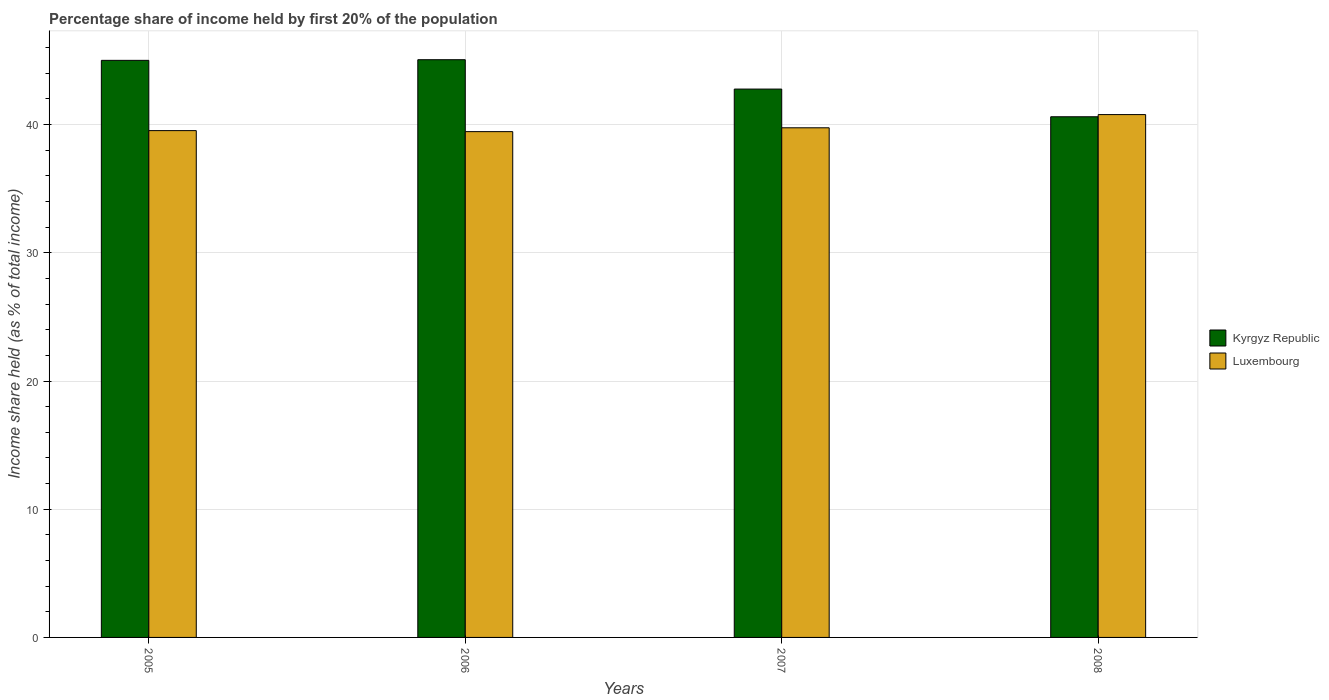How many groups of bars are there?
Provide a short and direct response. 4. How many bars are there on the 3rd tick from the left?
Offer a very short reply. 2. In how many cases, is the number of bars for a given year not equal to the number of legend labels?
Offer a very short reply. 0. What is the share of income held by first 20% of the population in Kyrgyz Republic in 2006?
Provide a short and direct response. 45.06. Across all years, what is the maximum share of income held by first 20% of the population in Luxembourg?
Make the answer very short. 40.78. Across all years, what is the minimum share of income held by first 20% of the population in Kyrgyz Republic?
Your response must be concise. 40.61. In which year was the share of income held by first 20% of the population in Luxembourg maximum?
Make the answer very short. 2008. In which year was the share of income held by first 20% of the population in Luxembourg minimum?
Offer a very short reply. 2006. What is the total share of income held by first 20% of the population in Kyrgyz Republic in the graph?
Provide a succinct answer. 173.45. What is the difference between the share of income held by first 20% of the population in Luxembourg in 2006 and that in 2007?
Keep it short and to the point. -0.3. What is the difference between the share of income held by first 20% of the population in Kyrgyz Republic in 2005 and the share of income held by first 20% of the population in Luxembourg in 2006?
Your answer should be compact. 5.56. What is the average share of income held by first 20% of the population in Kyrgyz Republic per year?
Offer a terse response. 43.36. In the year 2006, what is the difference between the share of income held by first 20% of the population in Luxembourg and share of income held by first 20% of the population in Kyrgyz Republic?
Provide a succinct answer. -5.61. What is the ratio of the share of income held by first 20% of the population in Kyrgyz Republic in 2005 to that in 2007?
Provide a short and direct response. 1.05. Is the difference between the share of income held by first 20% of the population in Luxembourg in 2006 and 2007 greater than the difference between the share of income held by first 20% of the population in Kyrgyz Republic in 2006 and 2007?
Ensure brevity in your answer.  No. What is the difference between the highest and the second highest share of income held by first 20% of the population in Luxembourg?
Your answer should be very brief. 1.03. What is the difference between the highest and the lowest share of income held by first 20% of the population in Kyrgyz Republic?
Your response must be concise. 4.45. What does the 1st bar from the left in 2005 represents?
Provide a succinct answer. Kyrgyz Republic. What does the 2nd bar from the right in 2007 represents?
Your response must be concise. Kyrgyz Republic. How many bars are there?
Make the answer very short. 8. How many years are there in the graph?
Your answer should be compact. 4. Does the graph contain grids?
Keep it short and to the point. Yes. Where does the legend appear in the graph?
Ensure brevity in your answer.  Center right. How many legend labels are there?
Your answer should be very brief. 2. How are the legend labels stacked?
Provide a short and direct response. Vertical. What is the title of the graph?
Offer a terse response. Percentage share of income held by first 20% of the population. Does "Colombia" appear as one of the legend labels in the graph?
Give a very brief answer. No. What is the label or title of the Y-axis?
Ensure brevity in your answer.  Income share held (as % of total income). What is the Income share held (as % of total income) of Kyrgyz Republic in 2005?
Keep it short and to the point. 45.01. What is the Income share held (as % of total income) in Luxembourg in 2005?
Your answer should be very brief. 39.53. What is the Income share held (as % of total income) in Kyrgyz Republic in 2006?
Give a very brief answer. 45.06. What is the Income share held (as % of total income) in Luxembourg in 2006?
Make the answer very short. 39.45. What is the Income share held (as % of total income) of Kyrgyz Republic in 2007?
Ensure brevity in your answer.  42.77. What is the Income share held (as % of total income) in Luxembourg in 2007?
Your response must be concise. 39.75. What is the Income share held (as % of total income) of Kyrgyz Republic in 2008?
Provide a succinct answer. 40.61. What is the Income share held (as % of total income) in Luxembourg in 2008?
Give a very brief answer. 40.78. Across all years, what is the maximum Income share held (as % of total income) of Kyrgyz Republic?
Give a very brief answer. 45.06. Across all years, what is the maximum Income share held (as % of total income) in Luxembourg?
Keep it short and to the point. 40.78. Across all years, what is the minimum Income share held (as % of total income) in Kyrgyz Republic?
Your answer should be very brief. 40.61. Across all years, what is the minimum Income share held (as % of total income) of Luxembourg?
Offer a terse response. 39.45. What is the total Income share held (as % of total income) in Kyrgyz Republic in the graph?
Offer a very short reply. 173.45. What is the total Income share held (as % of total income) in Luxembourg in the graph?
Your answer should be very brief. 159.51. What is the difference between the Income share held (as % of total income) in Kyrgyz Republic in 2005 and that in 2007?
Provide a succinct answer. 2.24. What is the difference between the Income share held (as % of total income) of Luxembourg in 2005 and that in 2007?
Keep it short and to the point. -0.22. What is the difference between the Income share held (as % of total income) of Luxembourg in 2005 and that in 2008?
Your answer should be compact. -1.25. What is the difference between the Income share held (as % of total income) of Kyrgyz Republic in 2006 and that in 2007?
Provide a short and direct response. 2.29. What is the difference between the Income share held (as % of total income) in Luxembourg in 2006 and that in 2007?
Provide a short and direct response. -0.3. What is the difference between the Income share held (as % of total income) of Kyrgyz Republic in 2006 and that in 2008?
Make the answer very short. 4.45. What is the difference between the Income share held (as % of total income) of Luxembourg in 2006 and that in 2008?
Your answer should be compact. -1.33. What is the difference between the Income share held (as % of total income) in Kyrgyz Republic in 2007 and that in 2008?
Keep it short and to the point. 2.16. What is the difference between the Income share held (as % of total income) of Luxembourg in 2007 and that in 2008?
Your answer should be compact. -1.03. What is the difference between the Income share held (as % of total income) of Kyrgyz Republic in 2005 and the Income share held (as % of total income) of Luxembourg in 2006?
Your response must be concise. 5.56. What is the difference between the Income share held (as % of total income) in Kyrgyz Republic in 2005 and the Income share held (as % of total income) in Luxembourg in 2007?
Give a very brief answer. 5.26. What is the difference between the Income share held (as % of total income) of Kyrgyz Republic in 2005 and the Income share held (as % of total income) of Luxembourg in 2008?
Offer a very short reply. 4.23. What is the difference between the Income share held (as % of total income) of Kyrgyz Republic in 2006 and the Income share held (as % of total income) of Luxembourg in 2007?
Offer a very short reply. 5.31. What is the difference between the Income share held (as % of total income) of Kyrgyz Republic in 2006 and the Income share held (as % of total income) of Luxembourg in 2008?
Keep it short and to the point. 4.28. What is the difference between the Income share held (as % of total income) of Kyrgyz Republic in 2007 and the Income share held (as % of total income) of Luxembourg in 2008?
Offer a terse response. 1.99. What is the average Income share held (as % of total income) of Kyrgyz Republic per year?
Keep it short and to the point. 43.36. What is the average Income share held (as % of total income) in Luxembourg per year?
Your answer should be very brief. 39.88. In the year 2005, what is the difference between the Income share held (as % of total income) in Kyrgyz Republic and Income share held (as % of total income) in Luxembourg?
Make the answer very short. 5.48. In the year 2006, what is the difference between the Income share held (as % of total income) in Kyrgyz Republic and Income share held (as % of total income) in Luxembourg?
Provide a short and direct response. 5.61. In the year 2007, what is the difference between the Income share held (as % of total income) in Kyrgyz Republic and Income share held (as % of total income) in Luxembourg?
Your answer should be very brief. 3.02. In the year 2008, what is the difference between the Income share held (as % of total income) in Kyrgyz Republic and Income share held (as % of total income) in Luxembourg?
Provide a succinct answer. -0.17. What is the ratio of the Income share held (as % of total income) in Kyrgyz Republic in 2005 to that in 2006?
Keep it short and to the point. 1. What is the ratio of the Income share held (as % of total income) in Luxembourg in 2005 to that in 2006?
Offer a very short reply. 1. What is the ratio of the Income share held (as % of total income) of Kyrgyz Republic in 2005 to that in 2007?
Your answer should be very brief. 1.05. What is the ratio of the Income share held (as % of total income) in Luxembourg in 2005 to that in 2007?
Provide a succinct answer. 0.99. What is the ratio of the Income share held (as % of total income) in Kyrgyz Republic in 2005 to that in 2008?
Your answer should be very brief. 1.11. What is the ratio of the Income share held (as % of total income) in Luxembourg in 2005 to that in 2008?
Your response must be concise. 0.97. What is the ratio of the Income share held (as % of total income) of Kyrgyz Republic in 2006 to that in 2007?
Make the answer very short. 1.05. What is the ratio of the Income share held (as % of total income) in Kyrgyz Republic in 2006 to that in 2008?
Provide a succinct answer. 1.11. What is the ratio of the Income share held (as % of total income) of Luxembourg in 2006 to that in 2008?
Keep it short and to the point. 0.97. What is the ratio of the Income share held (as % of total income) in Kyrgyz Republic in 2007 to that in 2008?
Give a very brief answer. 1.05. What is the ratio of the Income share held (as % of total income) of Luxembourg in 2007 to that in 2008?
Your answer should be compact. 0.97. What is the difference between the highest and the lowest Income share held (as % of total income) of Kyrgyz Republic?
Give a very brief answer. 4.45. What is the difference between the highest and the lowest Income share held (as % of total income) in Luxembourg?
Your answer should be very brief. 1.33. 